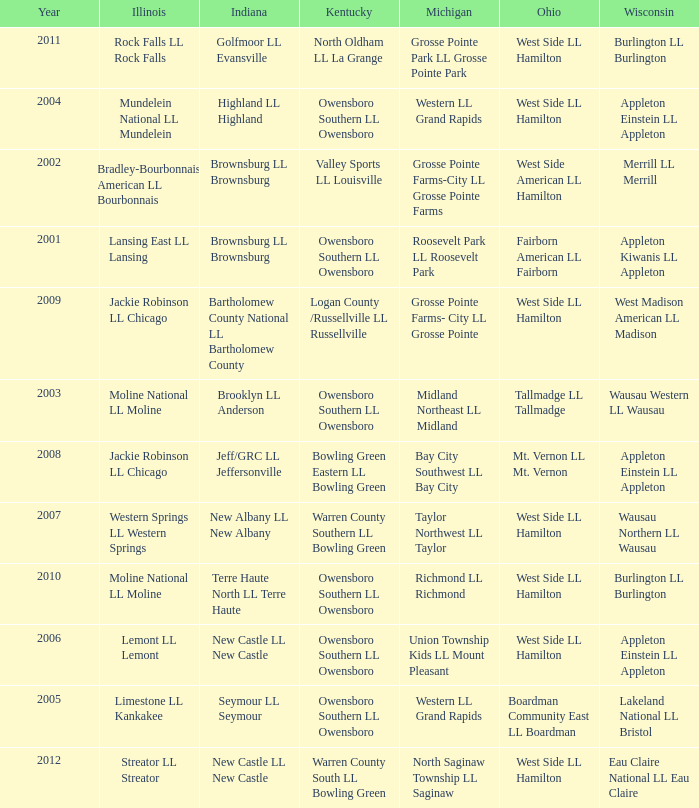What was the little league team from Ohio when the little league team from Kentucky was Warren County South LL Bowling Green? West Side LL Hamilton. 